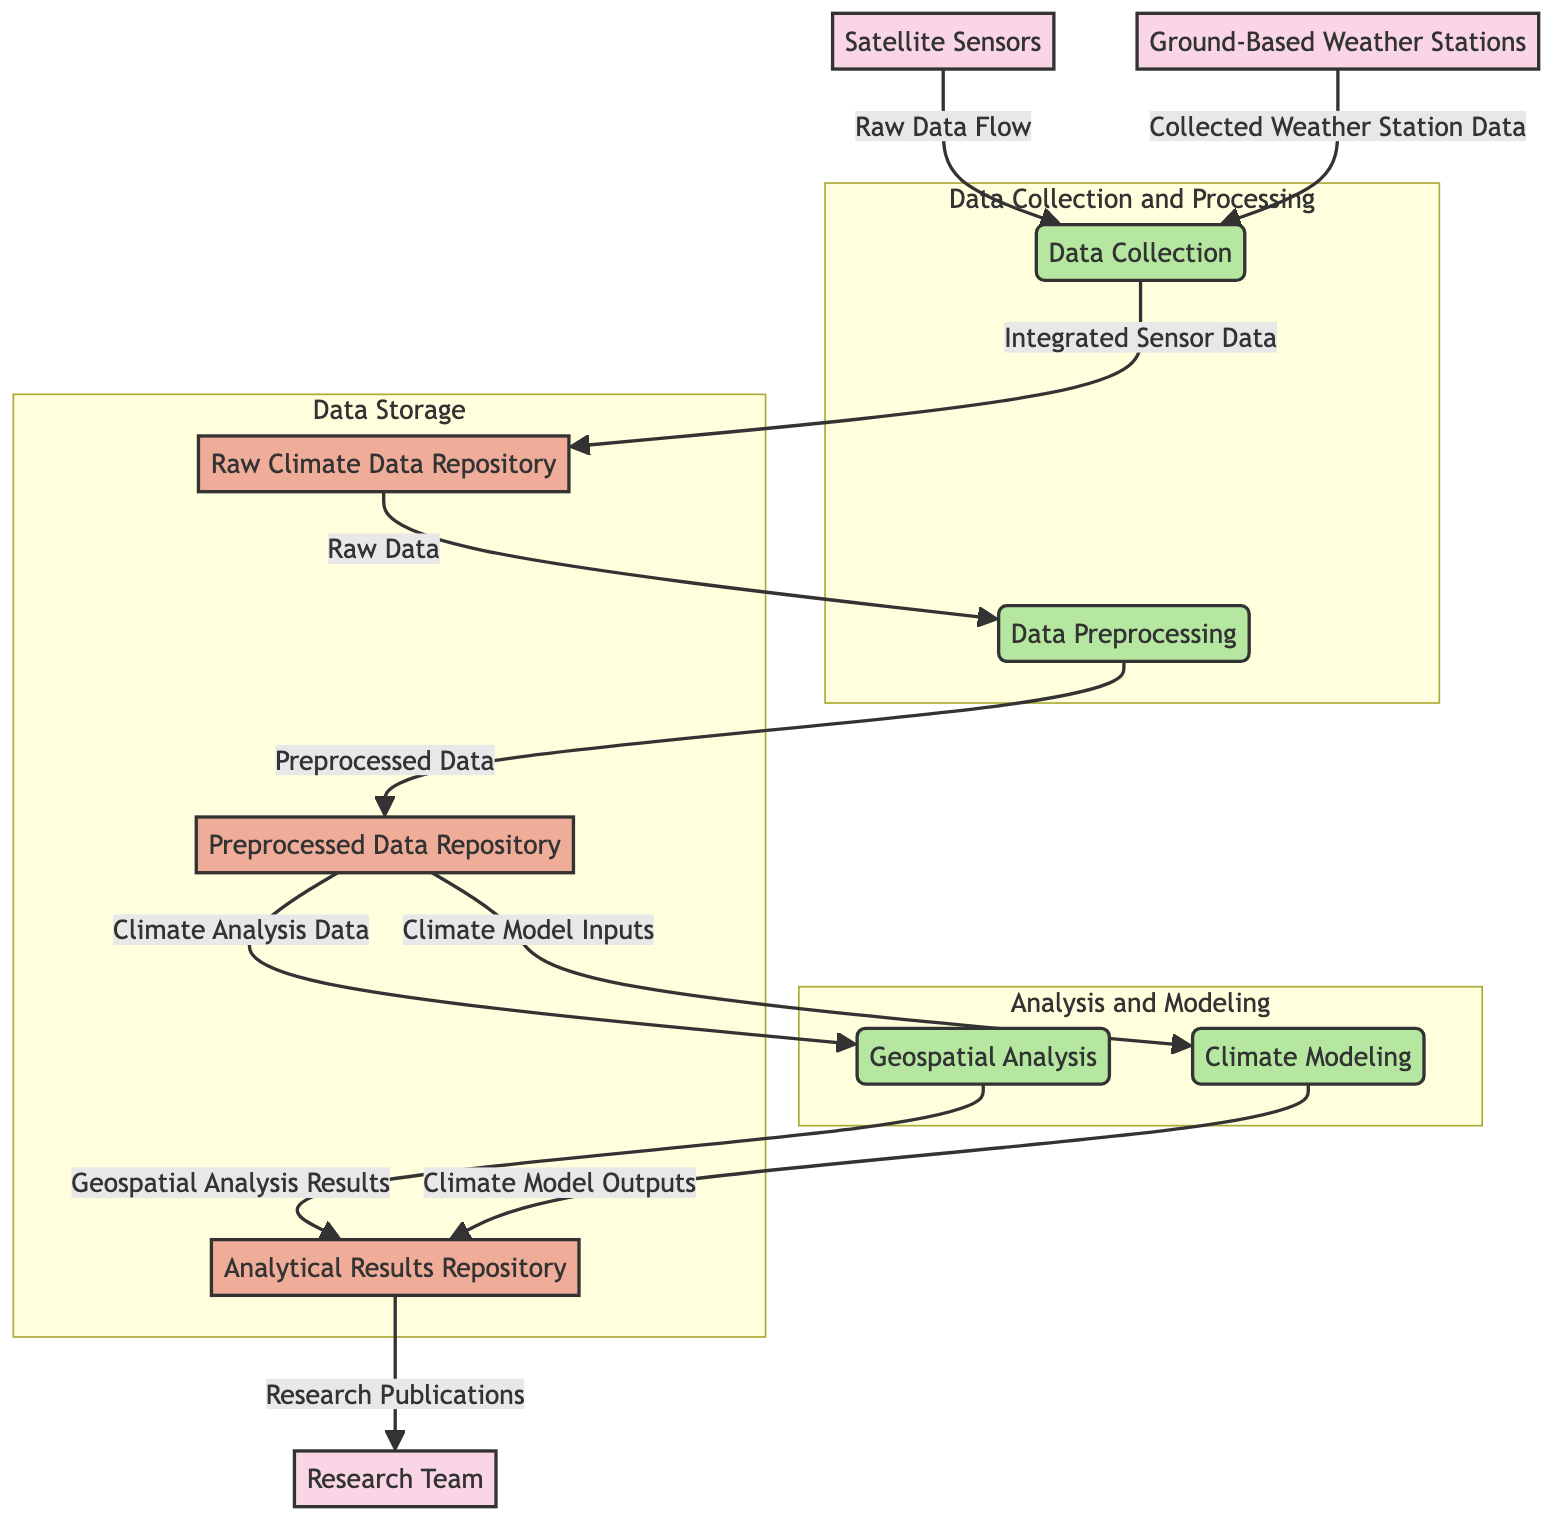What are the two external entities in this diagram? The diagram identifies two external entities: "Satellite Sensors" and "Ground-Based Weather Stations".
Answer: Satellite Sensors, Ground-Based Weather Stations How many processes are shown in the diagram? The diagram contains four processes: "Data Collection", "Data Preprocessing", "Geospatial Analysis", and "Climate Modeling".
Answer: Four What data flows into the "Data Collection" process? The "Data Collection" process receives data from two sources: "Satellite Sensors" (via "Raw Data Flow") and "Ground-Based Weather Stations" (via "Collected Weather Station Data").
Answer: Satellite Sensors, Ground-Based Weather Stations What is stored in the "Preprocessed Data Repository"? The "Preprocessed Data Repository" stores "Preprocessed Data" which is the output of the "Data Preprocessing" process.
Answer: Preprocessed Data What is the relationship between "Climate Modeling" and "Analytical Results Repository"? The "Climate Modeling" process sends its output named "Climate Model Outputs" to be stored in the "Analytical Results Repository".
Answer: Climate Model Outputs How does the data flow from the "Preprocessed Data Repository" to the "Geospatial Analysis"? Data flows named "Climate Analysis Data" are taken from the "Preprocessed Data Repository" and sent to the "Geospatial Analysis" process.
Answer: Climate Analysis Data What is the purpose of the "Research Team" in relation to the diagram? The "Research Team" utilizes the information stored in the "Analytical Results Repository" to produce "Research Publications", indicating they analyze results and disseminate findings.
Answer: Research Publications What data flow occurs from "Geospatial Analysis" to "Analytical Results Repository"? The output of the "Geospatial Analysis", termed "Geospatial Analysis Results", is sent to the "Analytical Results Repository".
Answer: Geospatial Analysis Results 